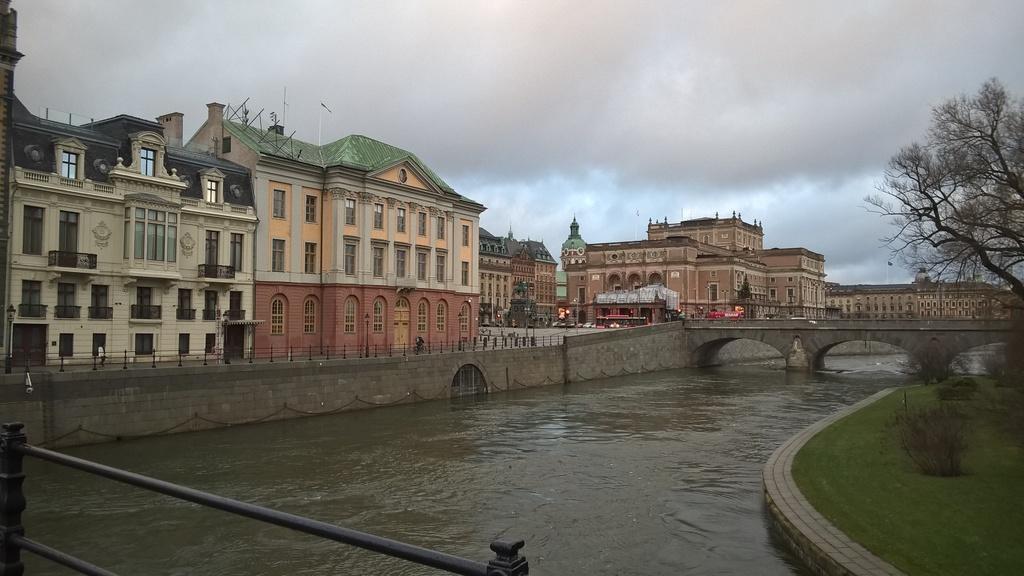Describe this image in one or two sentences. We can see water,grass,fence,plants and dried tree. In the background we can see buildings,fence and sky with clouds. 